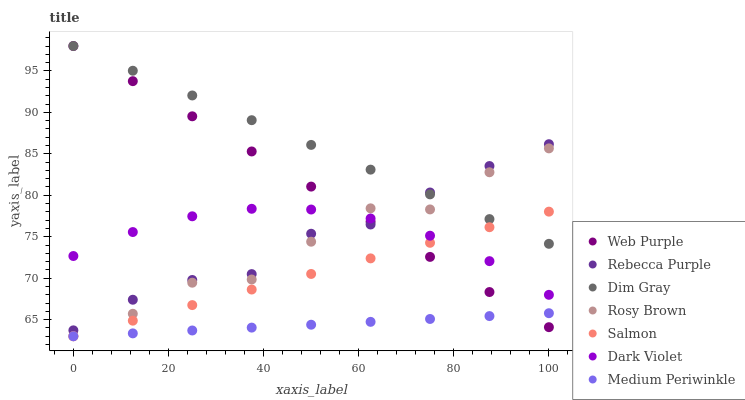Does Medium Periwinkle have the minimum area under the curve?
Answer yes or no. Yes. Does Dim Gray have the maximum area under the curve?
Answer yes or no. Yes. Does Rosy Brown have the minimum area under the curve?
Answer yes or no. No. Does Rosy Brown have the maximum area under the curve?
Answer yes or no. No. Is Medium Periwinkle the smoothest?
Answer yes or no. Yes. Is Rosy Brown the roughest?
Answer yes or no. Yes. Is Rosy Brown the smoothest?
Answer yes or no. No. Is Medium Periwinkle the roughest?
Answer yes or no. No. Does Medium Periwinkle have the lowest value?
Answer yes or no. Yes. Does Dark Violet have the lowest value?
Answer yes or no. No. Does Web Purple have the highest value?
Answer yes or no. Yes. Does Rosy Brown have the highest value?
Answer yes or no. No. Is Medium Periwinkle less than Dark Violet?
Answer yes or no. Yes. Is Rebecca Purple greater than Medium Periwinkle?
Answer yes or no. Yes. Does Dim Gray intersect Rosy Brown?
Answer yes or no. Yes. Is Dim Gray less than Rosy Brown?
Answer yes or no. No. Is Dim Gray greater than Rosy Brown?
Answer yes or no. No. Does Medium Periwinkle intersect Dark Violet?
Answer yes or no. No. 